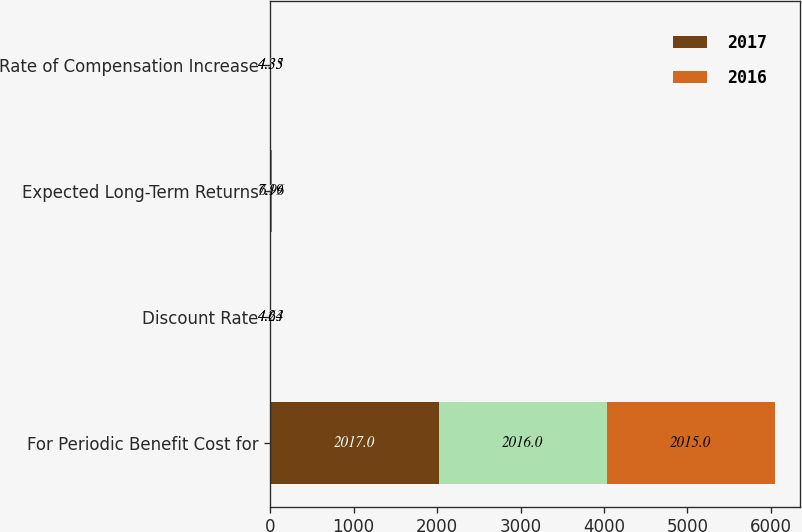<chart> <loc_0><loc_0><loc_500><loc_500><stacked_bar_chart><ecel><fcel>For Periodic Benefit Cost for<fcel>Discount Rate<fcel>Expected Long-Term Returns<fcel>Rate of Compensation Increase<nl><fcel>2017<fcel>2017<fcel>4.27<fcel>6.96<fcel>4.31<nl><fcel>nan<fcel>2016<fcel>4.64<fcel>7.19<fcel>4.33<nl><fcel>2016<fcel>2015<fcel>4.23<fcel>6.96<fcel>4.35<nl></chart> 